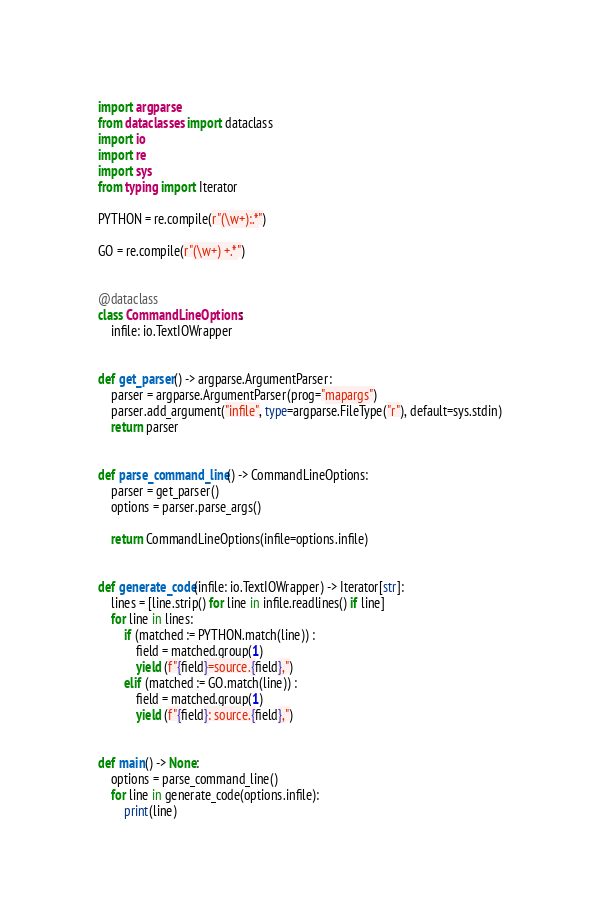Convert code to text. <code><loc_0><loc_0><loc_500><loc_500><_Python_>import argparse
from dataclasses import dataclass
import io
import re
import sys
from typing import Iterator

PYTHON = re.compile(r"(\w+):.*")

GO = re.compile(r"(\w+) +.*")


@dataclass
class CommandLineOptions:
    infile: io.TextIOWrapper


def get_parser() -> argparse.ArgumentParser:
    parser = argparse.ArgumentParser(prog="mapargs")
    parser.add_argument("infile", type=argparse.FileType("r"), default=sys.stdin)
    return parser


def parse_command_line() -> CommandLineOptions:
    parser = get_parser()
    options = parser.parse_args()

    return CommandLineOptions(infile=options.infile)


def generate_code(infile: io.TextIOWrapper) -> Iterator[str]:
    lines = [line.strip() for line in infile.readlines() if line]
    for line in lines:
        if (matched := PYTHON.match(line)) :
            field = matched.group(1)
            yield (f"{field}=source.{field},")
        elif (matched := GO.match(line)) :
            field = matched.group(1)
            yield (f"{field}: source.{field},")


def main() -> None:
    options = parse_command_line()
    for line in generate_code(options.infile):
        print(line)

</code> 